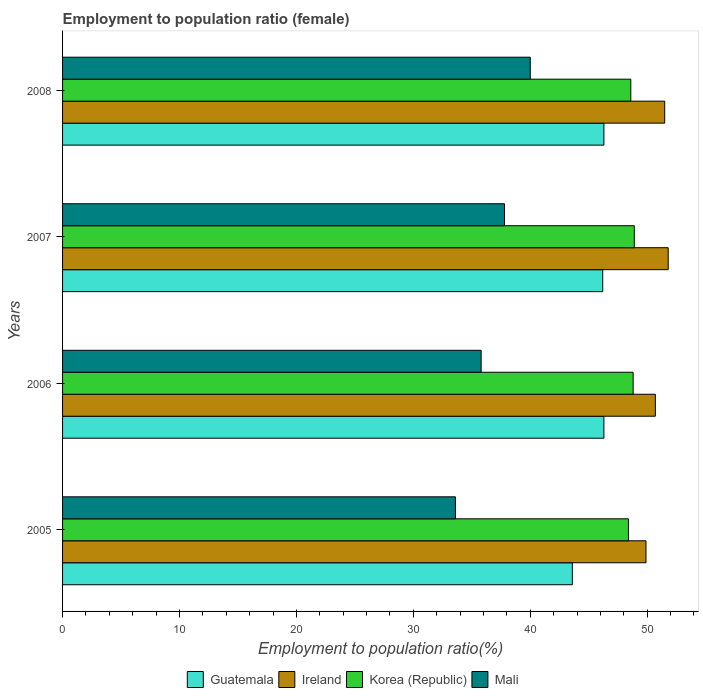How many different coloured bars are there?
Offer a terse response. 4. How many bars are there on the 2nd tick from the bottom?
Make the answer very short. 4. In how many cases, is the number of bars for a given year not equal to the number of legend labels?
Keep it short and to the point. 0. What is the employment to population ratio in Ireland in 2005?
Your response must be concise. 49.9. Across all years, what is the maximum employment to population ratio in Mali?
Your response must be concise. 40. Across all years, what is the minimum employment to population ratio in Mali?
Keep it short and to the point. 33.6. In which year was the employment to population ratio in Ireland minimum?
Make the answer very short. 2005. What is the total employment to population ratio in Ireland in the graph?
Offer a very short reply. 203.9. What is the difference between the employment to population ratio in Ireland in 2006 and that in 2008?
Provide a succinct answer. -0.8. What is the average employment to population ratio in Mali per year?
Ensure brevity in your answer.  36.8. In the year 2005, what is the difference between the employment to population ratio in Korea (Republic) and employment to population ratio in Ireland?
Provide a succinct answer. -1.5. In how many years, is the employment to population ratio in Guatemala greater than 14 %?
Ensure brevity in your answer.  4. What is the ratio of the employment to population ratio in Ireland in 2006 to that in 2007?
Provide a short and direct response. 0.98. Is the employment to population ratio in Ireland in 2005 less than that in 2008?
Keep it short and to the point. Yes. Is the difference between the employment to population ratio in Korea (Republic) in 2007 and 2008 greater than the difference between the employment to population ratio in Ireland in 2007 and 2008?
Your response must be concise. Yes. What is the difference between the highest and the second highest employment to population ratio in Korea (Republic)?
Keep it short and to the point. 0.1. What is the difference between the highest and the lowest employment to population ratio in Mali?
Your answer should be compact. 6.4. In how many years, is the employment to population ratio in Ireland greater than the average employment to population ratio in Ireland taken over all years?
Your answer should be very brief. 2. Is the sum of the employment to population ratio in Mali in 2005 and 2007 greater than the maximum employment to population ratio in Guatemala across all years?
Your answer should be compact. Yes. Is it the case that in every year, the sum of the employment to population ratio in Guatemala and employment to population ratio in Ireland is greater than the sum of employment to population ratio in Mali and employment to population ratio in Korea (Republic)?
Ensure brevity in your answer.  No. What does the 1st bar from the bottom in 2008 represents?
Offer a very short reply. Guatemala. Is it the case that in every year, the sum of the employment to population ratio in Mali and employment to population ratio in Guatemala is greater than the employment to population ratio in Korea (Republic)?
Provide a short and direct response. Yes. Are all the bars in the graph horizontal?
Keep it short and to the point. Yes. Does the graph contain any zero values?
Your response must be concise. No. Where does the legend appear in the graph?
Give a very brief answer. Bottom center. How many legend labels are there?
Provide a short and direct response. 4. What is the title of the graph?
Give a very brief answer. Employment to population ratio (female). What is the Employment to population ratio(%) in Guatemala in 2005?
Offer a terse response. 43.6. What is the Employment to population ratio(%) in Ireland in 2005?
Keep it short and to the point. 49.9. What is the Employment to population ratio(%) in Korea (Republic) in 2005?
Offer a very short reply. 48.4. What is the Employment to population ratio(%) of Mali in 2005?
Ensure brevity in your answer.  33.6. What is the Employment to population ratio(%) of Guatemala in 2006?
Make the answer very short. 46.3. What is the Employment to population ratio(%) of Ireland in 2006?
Offer a very short reply. 50.7. What is the Employment to population ratio(%) of Korea (Republic) in 2006?
Ensure brevity in your answer.  48.8. What is the Employment to population ratio(%) in Mali in 2006?
Your answer should be compact. 35.8. What is the Employment to population ratio(%) of Guatemala in 2007?
Offer a very short reply. 46.2. What is the Employment to population ratio(%) of Ireland in 2007?
Your answer should be very brief. 51.8. What is the Employment to population ratio(%) in Korea (Republic) in 2007?
Keep it short and to the point. 48.9. What is the Employment to population ratio(%) in Mali in 2007?
Ensure brevity in your answer.  37.8. What is the Employment to population ratio(%) of Guatemala in 2008?
Provide a short and direct response. 46.3. What is the Employment to population ratio(%) in Ireland in 2008?
Your response must be concise. 51.5. What is the Employment to population ratio(%) of Korea (Republic) in 2008?
Your answer should be very brief. 48.6. Across all years, what is the maximum Employment to population ratio(%) of Guatemala?
Your answer should be very brief. 46.3. Across all years, what is the maximum Employment to population ratio(%) of Ireland?
Keep it short and to the point. 51.8. Across all years, what is the maximum Employment to population ratio(%) in Korea (Republic)?
Give a very brief answer. 48.9. Across all years, what is the minimum Employment to population ratio(%) of Guatemala?
Your answer should be compact. 43.6. Across all years, what is the minimum Employment to population ratio(%) of Ireland?
Give a very brief answer. 49.9. Across all years, what is the minimum Employment to population ratio(%) of Korea (Republic)?
Provide a succinct answer. 48.4. Across all years, what is the minimum Employment to population ratio(%) of Mali?
Your answer should be compact. 33.6. What is the total Employment to population ratio(%) of Guatemala in the graph?
Make the answer very short. 182.4. What is the total Employment to population ratio(%) of Ireland in the graph?
Provide a short and direct response. 203.9. What is the total Employment to population ratio(%) in Korea (Republic) in the graph?
Keep it short and to the point. 194.7. What is the total Employment to population ratio(%) in Mali in the graph?
Offer a very short reply. 147.2. What is the difference between the Employment to population ratio(%) in Ireland in 2005 and that in 2006?
Provide a short and direct response. -0.8. What is the difference between the Employment to population ratio(%) of Mali in 2005 and that in 2006?
Give a very brief answer. -2.2. What is the difference between the Employment to population ratio(%) in Ireland in 2005 and that in 2007?
Your answer should be compact. -1.9. What is the difference between the Employment to population ratio(%) in Guatemala in 2005 and that in 2008?
Keep it short and to the point. -2.7. What is the difference between the Employment to population ratio(%) in Ireland in 2005 and that in 2008?
Make the answer very short. -1.6. What is the difference between the Employment to population ratio(%) in Korea (Republic) in 2005 and that in 2008?
Ensure brevity in your answer.  -0.2. What is the difference between the Employment to population ratio(%) in Mali in 2005 and that in 2008?
Give a very brief answer. -6.4. What is the difference between the Employment to population ratio(%) of Mali in 2006 and that in 2007?
Keep it short and to the point. -2. What is the difference between the Employment to population ratio(%) of Guatemala in 2006 and that in 2008?
Provide a short and direct response. 0. What is the difference between the Employment to population ratio(%) in Korea (Republic) in 2006 and that in 2008?
Make the answer very short. 0.2. What is the difference between the Employment to population ratio(%) of Guatemala in 2007 and that in 2008?
Give a very brief answer. -0.1. What is the difference between the Employment to population ratio(%) in Korea (Republic) in 2007 and that in 2008?
Offer a very short reply. 0.3. What is the difference between the Employment to population ratio(%) of Guatemala in 2005 and the Employment to population ratio(%) of Ireland in 2006?
Your answer should be compact. -7.1. What is the difference between the Employment to population ratio(%) of Guatemala in 2005 and the Employment to population ratio(%) of Mali in 2006?
Offer a very short reply. 7.8. What is the difference between the Employment to population ratio(%) in Guatemala in 2005 and the Employment to population ratio(%) in Ireland in 2007?
Your answer should be very brief. -8.2. What is the difference between the Employment to population ratio(%) in Guatemala in 2005 and the Employment to population ratio(%) in Korea (Republic) in 2007?
Keep it short and to the point. -5.3. What is the difference between the Employment to population ratio(%) in Guatemala in 2005 and the Employment to population ratio(%) in Korea (Republic) in 2008?
Offer a terse response. -5. What is the difference between the Employment to population ratio(%) of Guatemala in 2005 and the Employment to population ratio(%) of Mali in 2008?
Provide a short and direct response. 3.6. What is the difference between the Employment to population ratio(%) in Ireland in 2005 and the Employment to population ratio(%) in Korea (Republic) in 2008?
Your answer should be very brief. 1.3. What is the difference between the Employment to population ratio(%) of Ireland in 2005 and the Employment to population ratio(%) of Mali in 2008?
Ensure brevity in your answer.  9.9. What is the difference between the Employment to population ratio(%) in Korea (Republic) in 2005 and the Employment to population ratio(%) in Mali in 2008?
Ensure brevity in your answer.  8.4. What is the difference between the Employment to population ratio(%) in Guatemala in 2006 and the Employment to population ratio(%) in Ireland in 2007?
Offer a very short reply. -5.5. What is the difference between the Employment to population ratio(%) of Guatemala in 2006 and the Employment to population ratio(%) of Korea (Republic) in 2007?
Your answer should be very brief. -2.6. What is the difference between the Employment to population ratio(%) in Korea (Republic) in 2006 and the Employment to population ratio(%) in Mali in 2007?
Keep it short and to the point. 11. What is the difference between the Employment to population ratio(%) in Ireland in 2006 and the Employment to population ratio(%) in Korea (Republic) in 2008?
Ensure brevity in your answer.  2.1. What is the difference between the Employment to population ratio(%) in Ireland in 2006 and the Employment to population ratio(%) in Mali in 2008?
Your response must be concise. 10.7. What is the difference between the Employment to population ratio(%) of Guatemala in 2007 and the Employment to population ratio(%) of Ireland in 2008?
Offer a terse response. -5.3. What is the difference between the Employment to population ratio(%) in Ireland in 2007 and the Employment to population ratio(%) in Korea (Republic) in 2008?
Your answer should be compact. 3.2. What is the difference between the Employment to population ratio(%) in Ireland in 2007 and the Employment to population ratio(%) in Mali in 2008?
Ensure brevity in your answer.  11.8. What is the difference between the Employment to population ratio(%) in Korea (Republic) in 2007 and the Employment to population ratio(%) in Mali in 2008?
Make the answer very short. 8.9. What is the average Employment to population ratio(%) in Guatemala per year?
Your answer should be very brief. 45.6. What is the average Employment to population ratio(%) in Ireland per year?
Keep it short and to the point. 50.98. What is the average Employment to population ratio(%) of Korea (Republic) per year?
Your answer should be very brief. 48.67. What is the average Employment to population ratio(%) in Mali per year?
Provide a short and direct response. 36.8. In the year 2005, what is the difference between the Employment to population ratio(%) of Ireland and Employment to population ratio(%) of Korea (Republic)?
Give a very brief answer. 1.5. In the year 2006, what is the difference between the Employment to population ratio(%) of Guatemala and Employment to population ratio(%) of Ireland?
Make the answer very short. -4.4. In the year 2006, what is the difference between the Employment to population ratio(%) in Ireland and Employment to population ratio(%) in Korea (Republic)?
Your answer should be compact. 1.9. In the year 2006, what is the difference between the Employment to population ratio(%) in Ireland and Employment to population ratio(%) in Mali?
Your answer should be very brief. 14.9. In the year 2006, what is the difference between the Employment to population ratio(%) in Korea (Republic) and Employment to population ratio(%) in Mali?
Ensure brevity in your answer.  13. In the year 2007, what is the difference between the Employment to population ratio(%) of Guatemala and Employment to population ratio(%) of Korea (Republic)?
Offer a very short reply. -2.7. In the year 2007, what is the difference between the Employment to population ratio(%) in Korea (Republic) and Employment to population ratio(%) in Mali?
Your response must be concise. 11.1. In the year 2008, what is the difference between the Employment to population ratio(%) of Guatemala and Employment to population ratio(%) of Korea (Republic)?
Give a very brief answer. -2.3. What is the ratio of the Employment to population ratio(%) in Guatemala in 2005 to that in 2006?
Make the answer very short. 0.94. What is the ratio of the Employment to population ratio(%) in Ireland in 2005 to that in 2006?
Give a very brief answer. 0.98. What is the ratio of the Employment to population ratio(%) of Korea (Republic) in 2005 to that in 2006?
Provide a short and direct response. 0.99. What is the ratio of the Employment to population ratio(%) in Mali in 2005 to that in 2006?
Your answer should be compact. 0.94. What is the ratio of the Employment to population ratio(%) in Guatemala in 2005 to that in 2007?
Ensure brevity in your answer.  0.94. What is the ratio of the Employment to population ratio(%) of Ireland in 2005 to that in 2007?
Make the answer very short. 0.96. What is the ratio of the Employment to population ratio(%) in Korea (Republic) in 2005 to that in 2007?
Your response must be concise. 0.99. What is the ratio of the Employment to population ratio(%) of Guatemala in 2005 to that in 2008?
Your answer should be compact. 0.94. What is the ratio of the Employment to population ratio(%) in Ireland in 2005 to that in 2008?
Make the answer very short. 0.97. What is the ratio of the Employment to population ratio(%) of Mali in 2005 to that in 2008?
Keep it short and to the point. 0.84. What is the ratio of the Employment to population ratio(%) of Guatemala in 2006 to that in 2007?
Provide a short and direct response. 1. What is the ratio of the Employment to population ratio(%) of Ireland in 2006 to that in 2007?
Offer a terse response. 0.98. What is the ratio of the Employment to population ratio(%) of Mali in 2006 to that in 2007?
Offer a very short reply. 0.95. What is the ratio of the Employment to population ratio(%) of Guatemala in 2006 to that in 2008?
Keep it short and to the point. 1. What is the ratio of the Employment to population ratio(%) of Ireland in 2006 to that in 2008?
Ensure brevity in your answer.  0.98. What is the ratio of the Employment to population ratio(%) in Korea (Republic) in 2006 to that in 2008?
Your answer should be compact. 1. What is the ratio of the Employment to population ratio(%) of Mali in 2006 to that in 2008?
Keep it short and to the point. 0.9. What is the ratio of the Employment to population ratio(%) in Ireland in 2007 to that in 2008?
Give a very brief answer. 1.01. What is the ratio of the Employment to population ratio(%) of Korea (Republic) in 2007 to that in 2008?
Offer a very short reply. 1.01. What is the ratio of the Employment to population ratio(%) in Mali in 2007 to that in 2008?
Your response must be concise. 0.94. What is the difference between the highest and the second highest Employment to population ratio(%) of Guatemala?
Make the answer very short. 0. What is the difference between the highest and the second highest Employment to population ratio(%) in Ireland?
Offer a terse response. 0.3. What is the difference between the highest and the second highest Employment to population ratio(%) of Korea (Republic)?
Provide a succinct answer. 0.1. What is the difference between the highest and the lowest Employment to population ratio(%) of Guatemala?
Your answer should be compact. 2.7. 